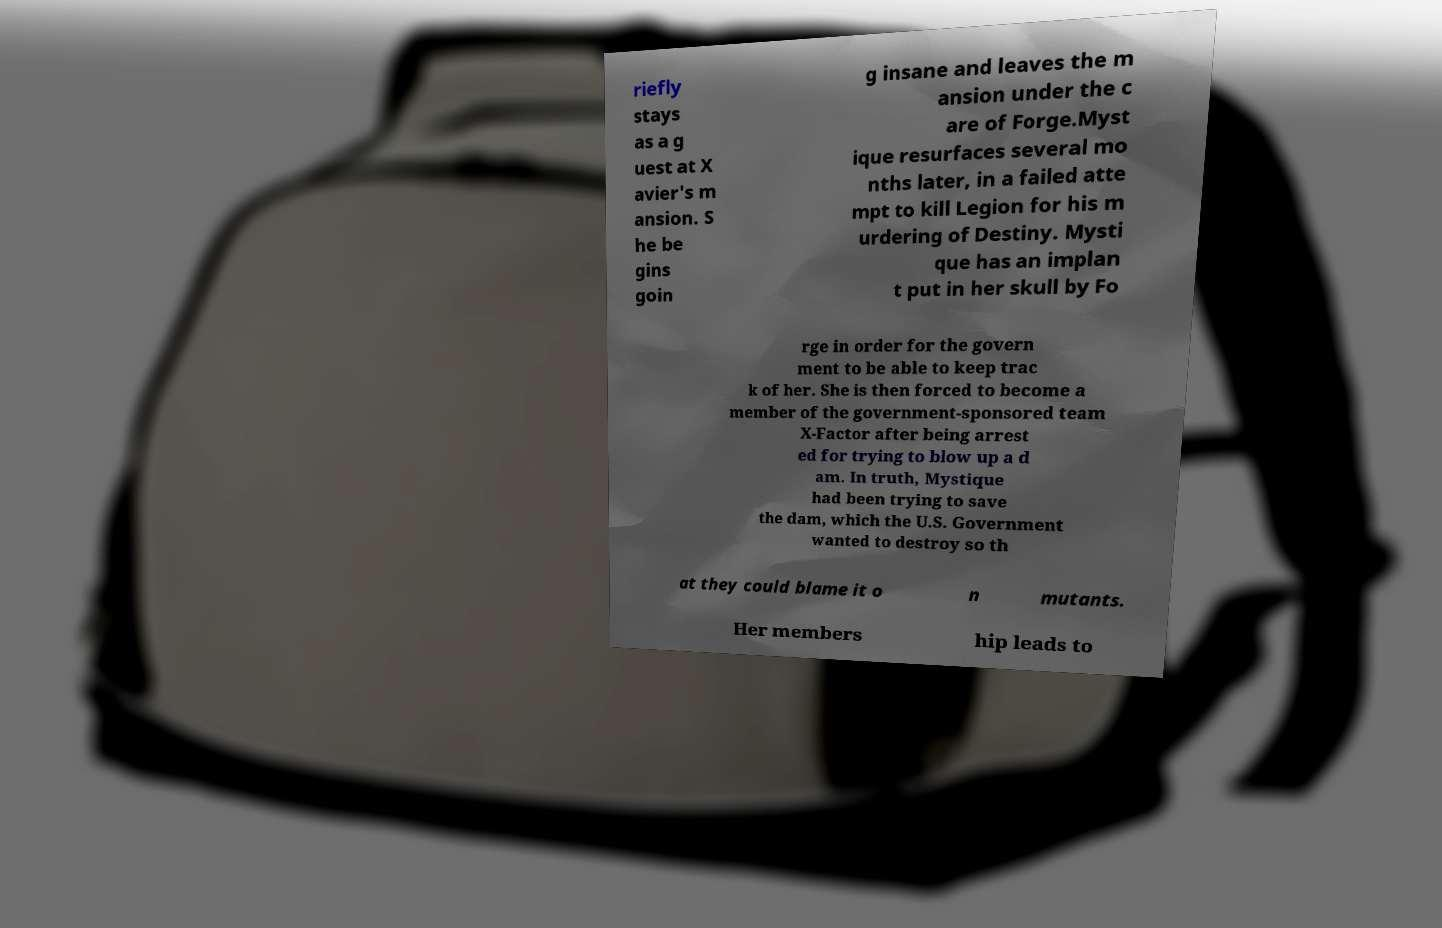For documentation purposes, I need the text within this image transcribed. Could you provide that? riefly stays as a g uest at X avier's m ansion. S he be gins goin g insane and leaves the m ansion under the c are of Forge.Myst ique resurfaces several mo nths later, in a failed atte mpt to kill Legion for his m urdering of Destiny. Mysti que has an implan t put in her skull by Fo rge in order for the govern ment to be able to keep trac k of her. She is then forced to become a member of the government-sponsored team X-Factor after being arrest ed for trying to blow up a d am. In truth, Mystique had been trying to save the dam, which the U.S. Government wanted to destroy so th at they could blame it o n mutants. Her members hip leads to 